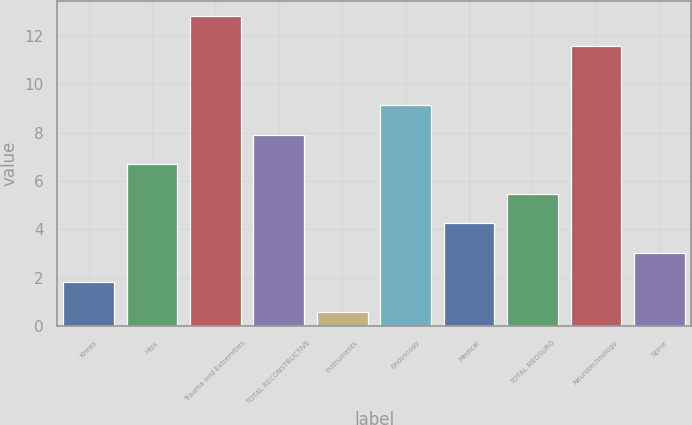Convert chart. <chart><loc_0><loc_0><loc_500><loc_500><bar_chart><fcel>Knees<fcel>Hips<fcel>Trauma and Extremities<fcel>TOTAL RECONSTRUCTIVE<fcel>Instruments<fcel>Endoscopy<fcel>Medical<fcel>TOTAL MEDSURG<fcel>Neurotechnology<fcel>Spine<nl><fcel>1.82<fcel>6.7<fcel>12.8<fcel>7.92<fcel>0.6<fcel>9.14<fcel>4.26<fcel>5.48<fcel>11.58<fcel>3.04<nl></chart> 